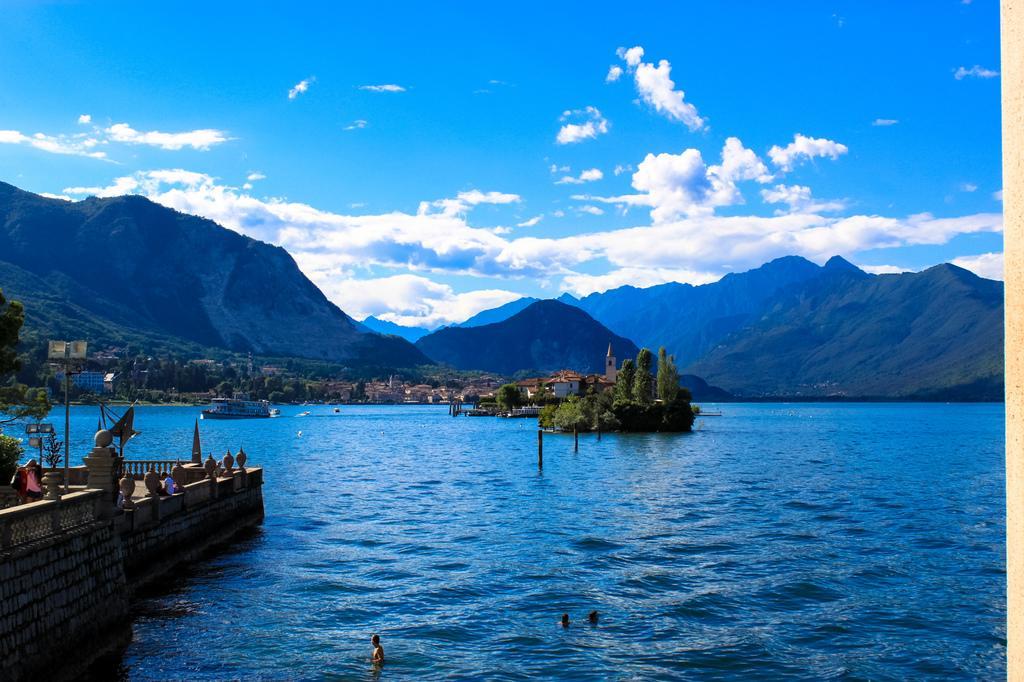Describe this image in one or two sentences. In this image there is a boat sailing on the surface of the water. Left side there is a fence. Behind there are plants on the floor. A person is sitting on the wall. Few lights are attached to the pole. Middle of the image there are plants, trees and buildings on the land. Background there are hills. Top of the image there is sky with some clouds. Bottom of the image there are people in the water. 